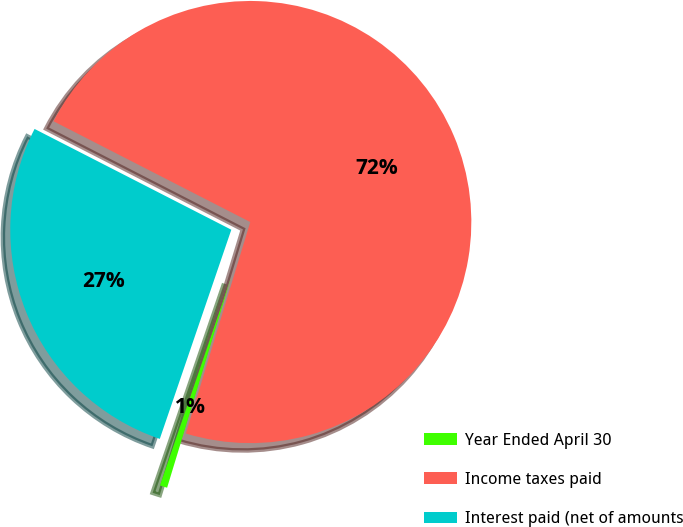<chart> <loc_0><loc_0><loc_500><loc_500><pie_chart><fcel>Year Ended April 30<fcel>Income taxes paid<fcel>Interest paid (net of amounts<nl><fcel>0.54%<fcel>72.17%<fcel>27.29%<nl></chart> 